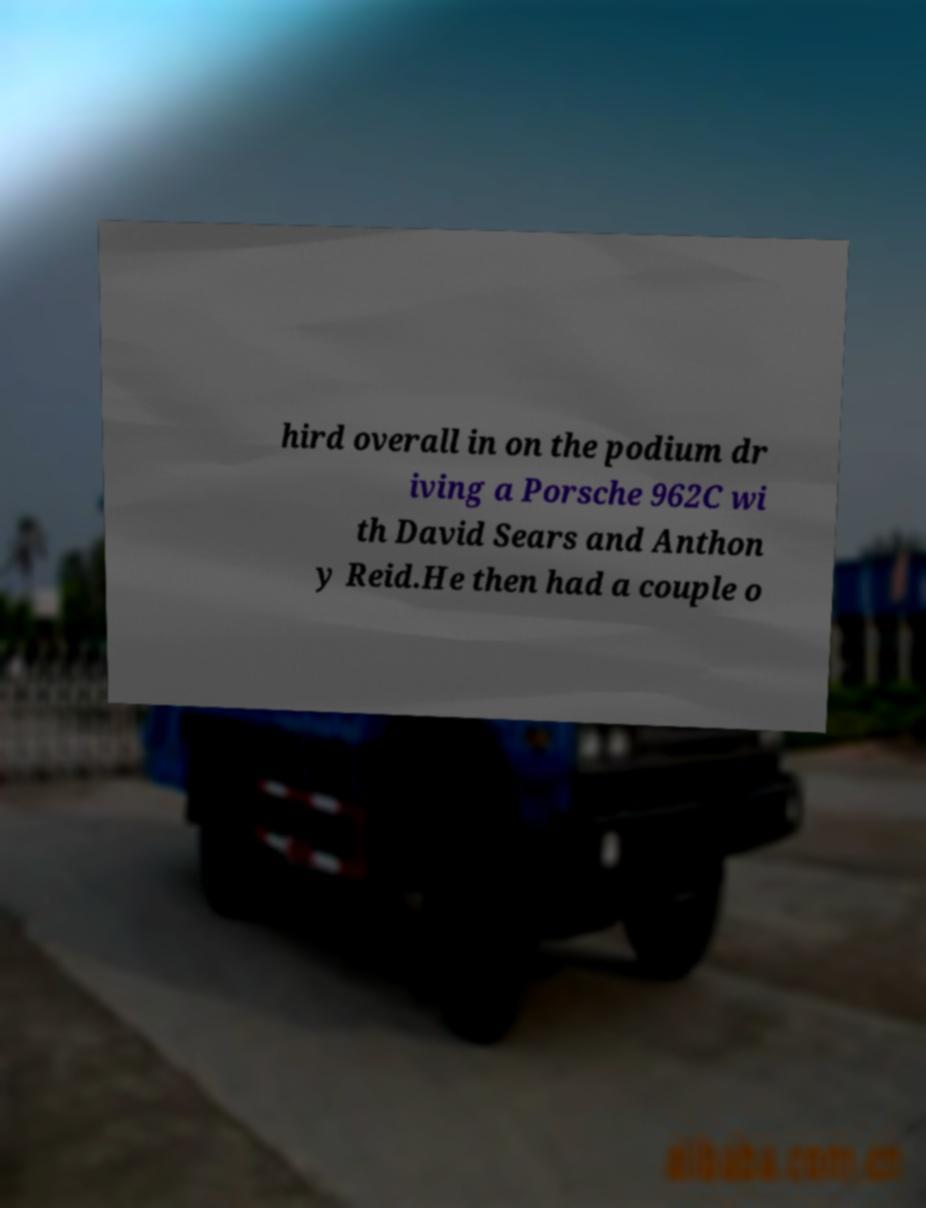For documentation purposes, I need the text within this image transcribed. Could you provide that? hird overall in on the podium dr iving a Porsche 962C wi th David Sears and Anthon y Reid.He then had a couple o 